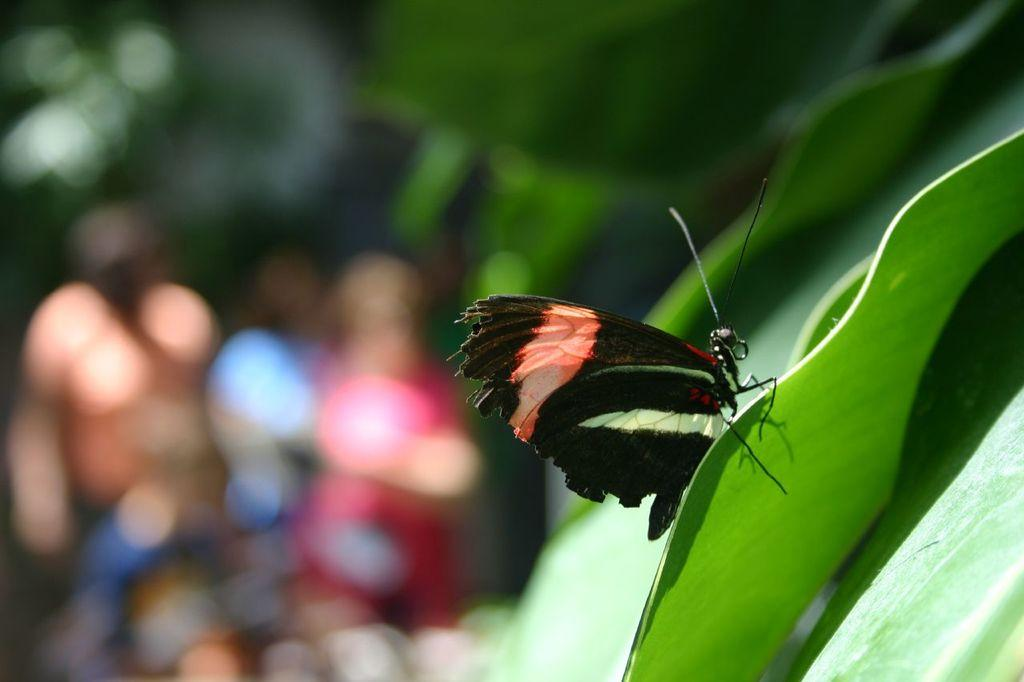What type of insect is in the image? There is a black butterfly in the image. Where is the butterfly located? The butterfly is on a leaf. Can you describe the background of the image? The background of the image is blurred. How much yarn is on the desk in the image? There is no yarn or desk present in the image. 